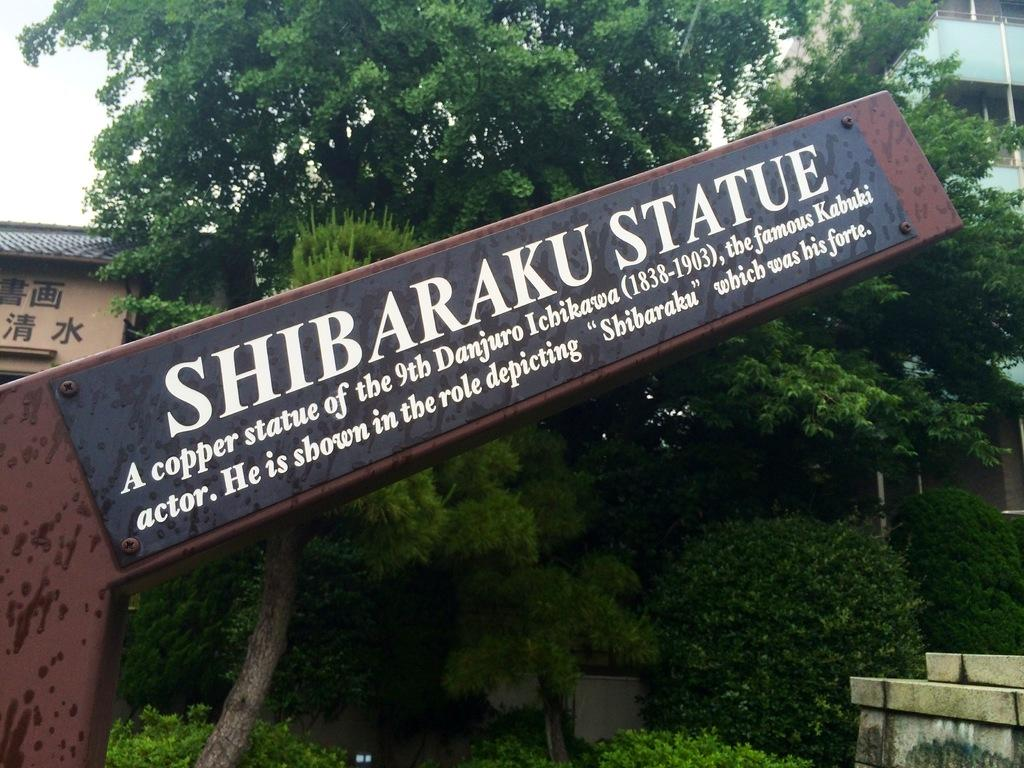What is the color of the pole in the image? The pole in the image is brown colored. What is attached to the pole? There is a black colored board attached to the pole. What can be seen in the background of the image? There are buildings, trees, and the sky visible in the background of the image. How many flowers are hanging from the string in the image? There is no string or flowers present in the image. What type of bubble can be seen floating near the pole? There is no bubble present in the image. 